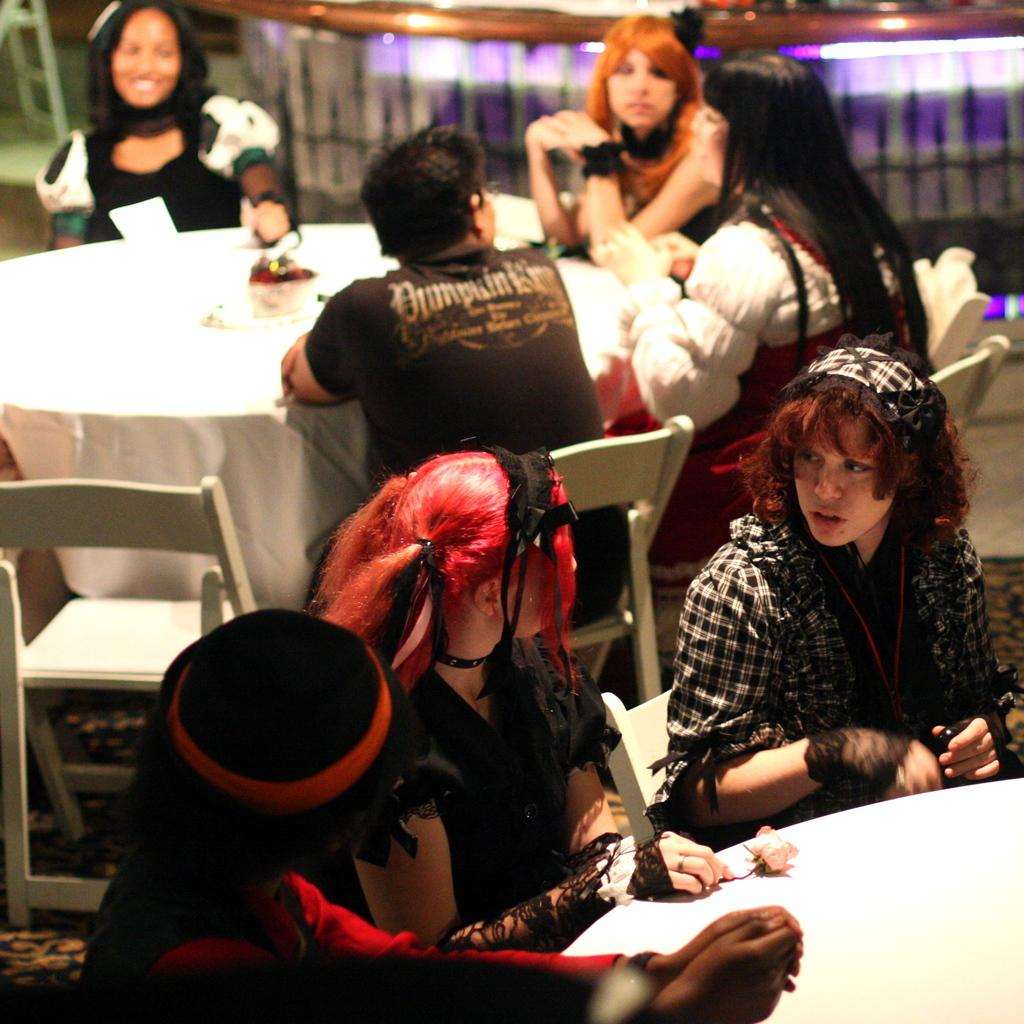What are the women in the image doing? The women are sitting in the chairs. What objects can be seen in the image besides the women? There are tables in the image. Can you describe any other objects or features in the image? There appears to be a ladder in the top left corner of the image. What type of plastic pail is being used by the women to low the ladder in the image? There is no plastic pail or any indication of the women using a pail to low the ladder in the image. 